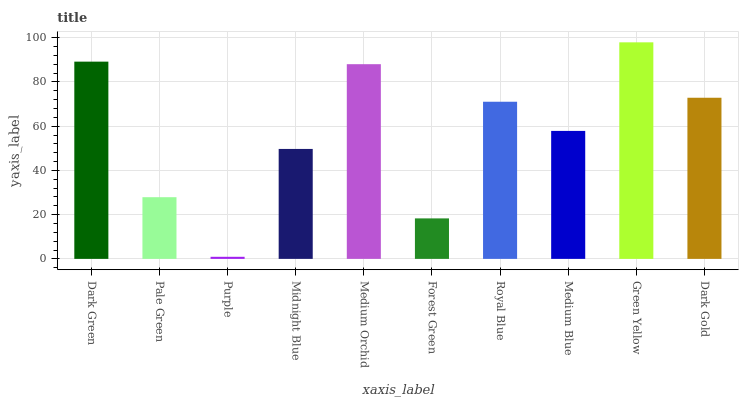Is Purple the minimum?
Answer yes or no. Yes. Is Green Yellow the maximum?
Answer yes or no. Yes. Is Pale Green the minimum?
Answer yes or no. No. Is Pale Green the maximum?
Answer yes or no. No. Is Dark Green greater than Pale Green?
Answer yes or no. Yes. Is Pale Green less than Dark Green?
Answer yes or no. Yes. Is Pale Green greater than Dark Green?
Answer yes or no. No. Is Dark Green less than Pale Green?
Answer yes or no. No. Is Royal Blue the high median?
Answer yes or no. Yes. Is Medium Blue the low median?
Answer yes or no. Yes. Is Pale Green the high median?
Answer yes or no. No. Is Royal Blue the low median?
Answer yes or no. No. 